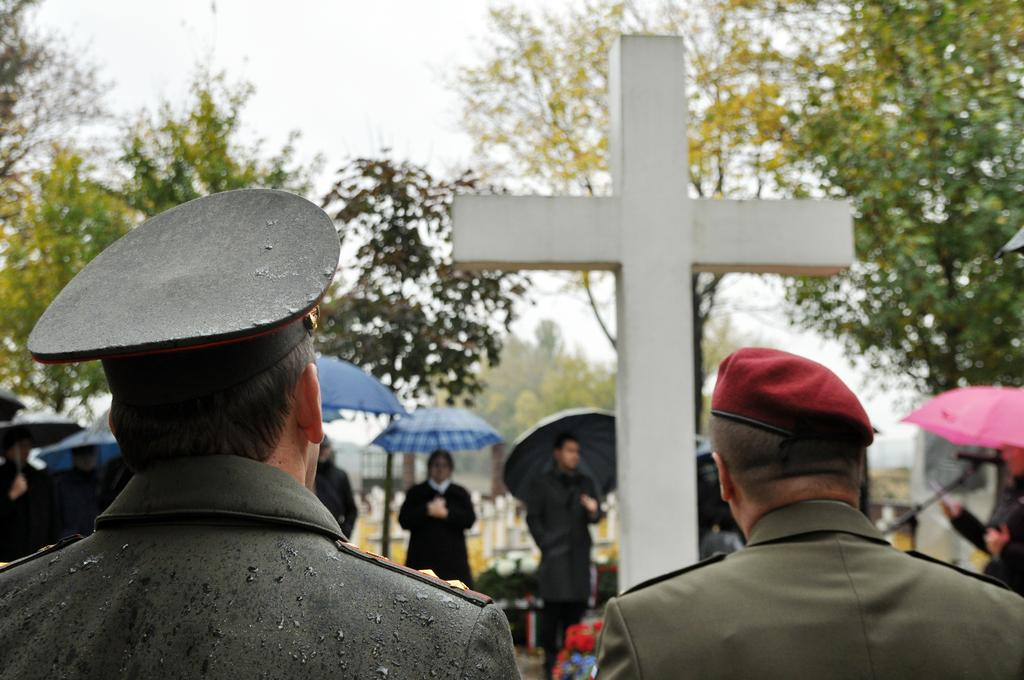What are the people in the image doing? The people in the image are standing and holding umbrellas. What can be seen in the center of the image? There is a cross in the center of the image. What is visible in the background of the image? There are trees and the sky visible in the background of the image. What type of plants can be seen growing in the wilderness in the image? There is no wilderness or plants visible in the image; it features people holding umbrellas, a cross, trees, and the sky. 